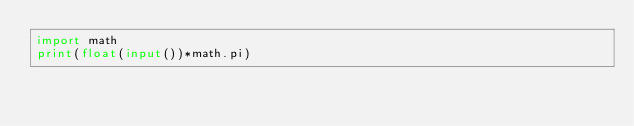Convert code to text. <code><loc_0><loc_0><loc_500><loc_500><_Python_>import math
print(float(input())*math.pi)</code> 